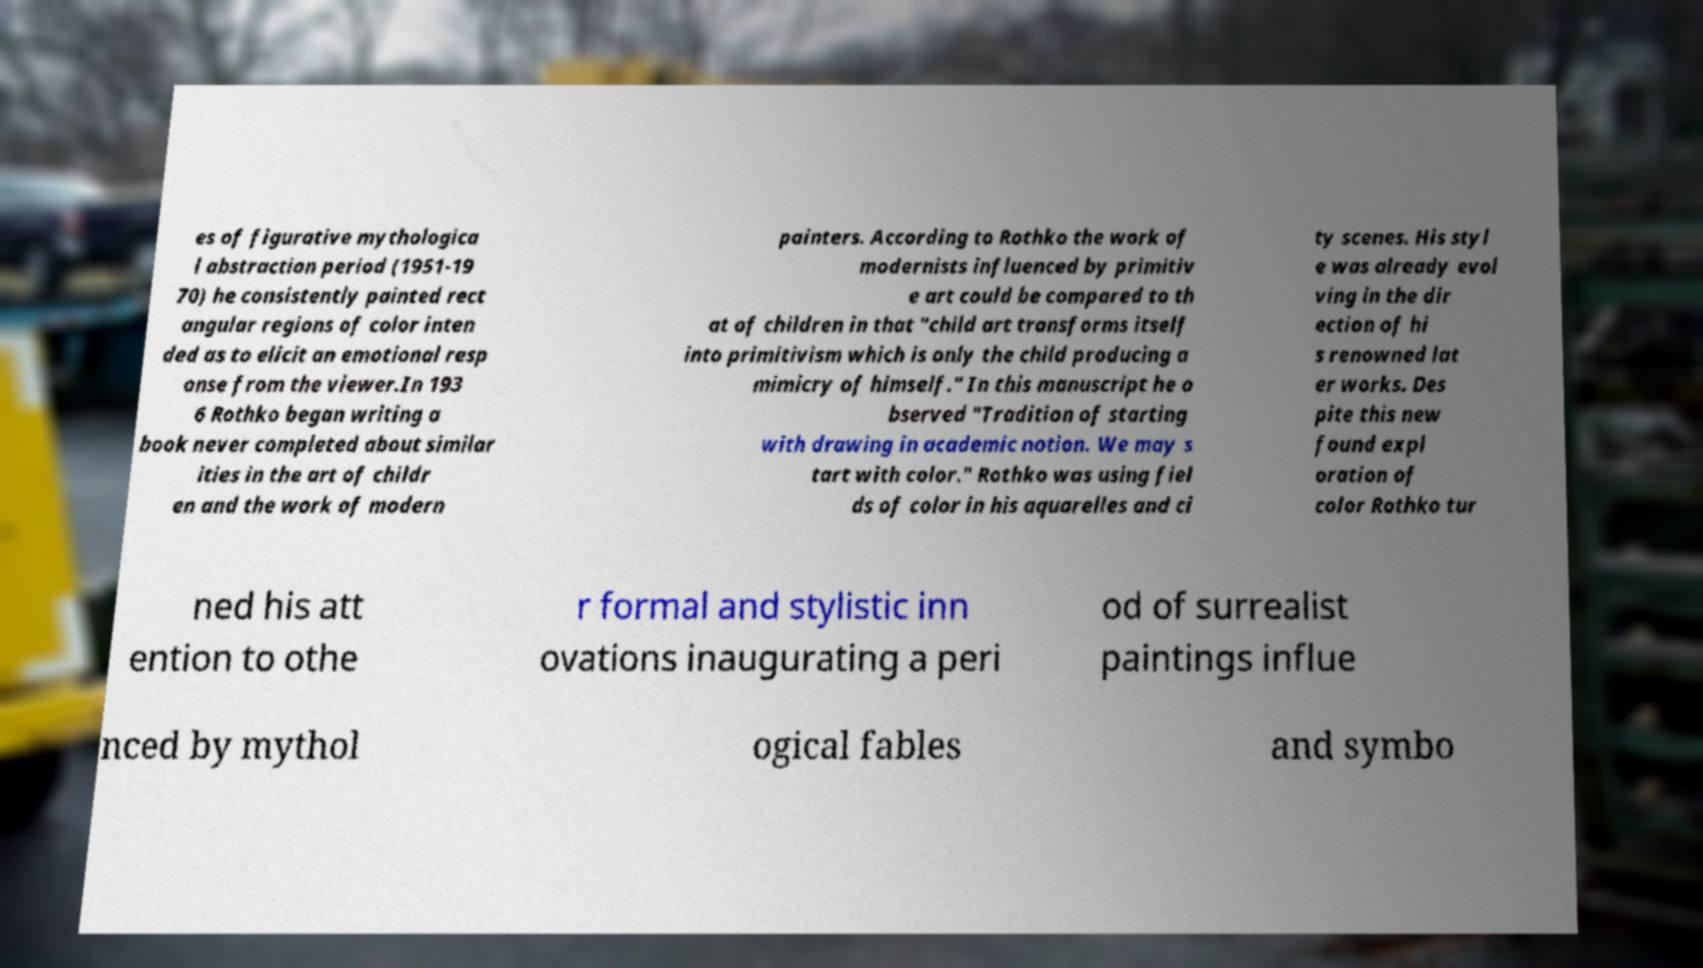Please read and relay the text visible in this image. What does it say? es of figurative mythologica l abstraction period (1951-19 70) he consistently painted rect angular regions of color inten ded as to elicit an emotional resp onse from the viewer.In 193 6 Rothko began writing a book never completed about similar ities in the art of childr en and the work of modern painters. According to Rothko the work of modernists influenced by primitiv e art could be compared to th at of children in that "child art transforms itself into primitivism which is only the child producing a mimicry of himself." In this manuscript he o bserved "Tradition of starting with drawing in academic notion. We may s tart with color." Rothko was using fiel ds of color in his aquarelles and ci ty scenes. His styl e was already evol ving in the dir ection of hi s renowned lat er works. Des pite this new found expl oration of color Rothko tur ned his att ention to othe r formal and stylistic inn ovations inaugurating a peri od of surrealist paintings influe nced by mythol ogical fables and symbo 